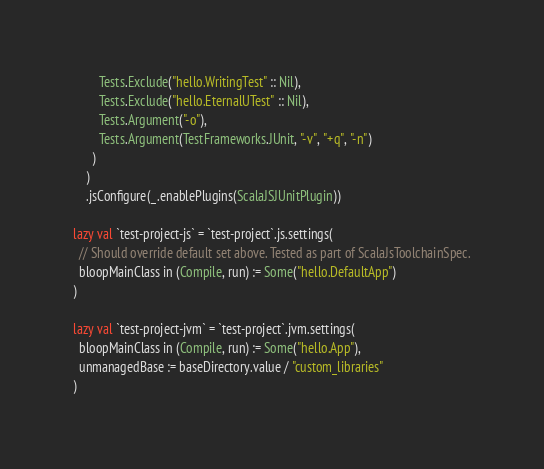<code> <loc_0><loc_0><loc_500><loc_500><_Scala_>        Tests.Exclude("hello.WritingTest" :: Nil),
        Tests.Exclude("hello.EternalUTest" :: Nil),
        Tests.Argument("-o"),
        Tests.Argument(TestFrameworks.JUnit, "-v", "+q", "-n")
      )
    )
    .jsConfigure(_.enablePlugins(ScalaJSJUnitPlugin))

lazy val `test-project-js` = `test-project`.js.settings(
  // Should override default set above. Tested as part of ScalaJsToolchainSpec.
  bloopMainClass in (Compile, run) := Some("hello.DefaultApp")
)

lazy val `test-project-jvm` = `test-project`.jvm.settings(
  bloopMainClass in (Compile, run) := Some("hello.App"),
  unmanagedBase := baseDirectory.value / "custom_libraries"
)
</code> 